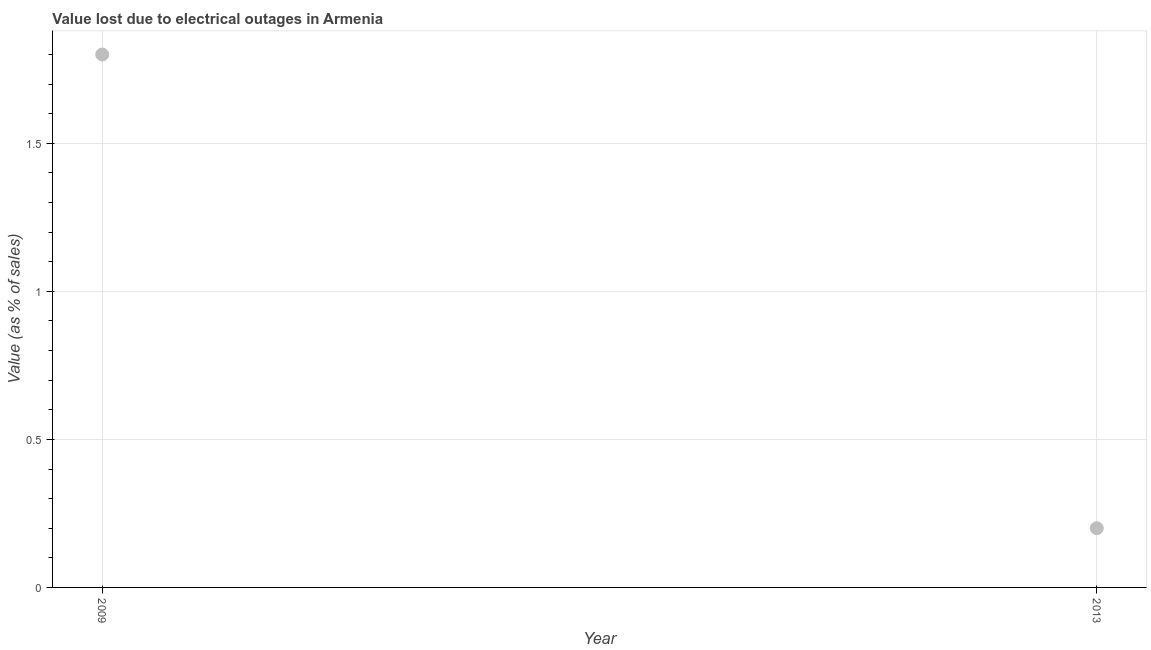What is the value lost due to electrical outages in 2013?
Make the answer very short. 0.2. Across all years, what is the minimum value lost due to electrical outages?
Give a very brief answer. 0.2. In which year was the value lost due to electrical outages minimum?
Your answer should be compact. 2013. What is the sum of the value lost due to electrical outages?
Offer a very short reply. 2. In how many years, is the value lost due to electrical outages greater than 0.8 %?
Make the answer very short. 1. Do a majority of the years between 2009 and 2013 (inclusive) have value lost due to electrical outages greater than 1.7 %?
Offer a very short reply. No. What is the ratio of the value lost due to electrical outages in 2009 to that in 2013?
Your answer should be very brief. 9. In how many years, is the value lost due to electrical outages greater than the average value lost due to electrical outages taken over all years?
Keep it short and to the point. 1. Does the value lost due to electrical outages monotonically increase over the years?
Make the answer very short. No. How many years are there in the graph?
Ensure brevity in your answer.  2. Are the values on the major ticks of Y-axis written in scientific E-notation?
Ensure brevity in your answer.  No. Does the graph contain any zero values?
Your response must be concise. No. Does the graph contain grids?
Offer a very short reply. Yes. What is the title of the graph?
Provide a short and direct response. Value lost due to electrical outages in Armenia. What is the label or title of the Y-axis?
Give a very brief answer. Value (as % of sales). 